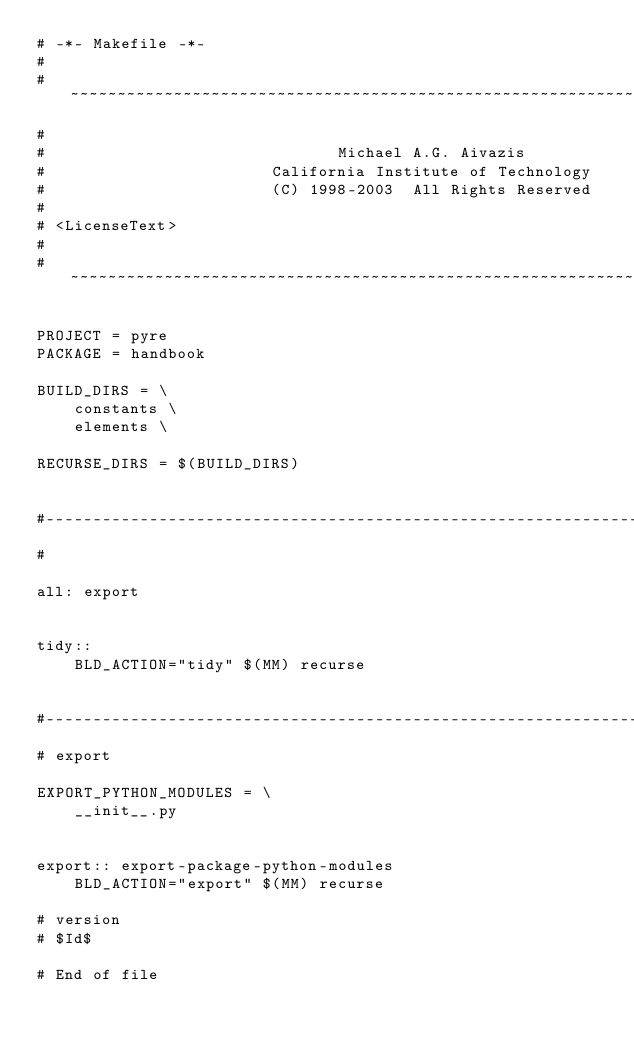Convert code to text. <code><loc_0><loc_0><loc_500><loc_500><_ObjectiveC_># -*- Makefile -*-
#
# ~~~~~~~~~~~~~~~~~~~~~~~~~~~~~~~~~~~~~~~~~~~~~~~~~~~~~~~~~~~~~~~~~~~~~~~~~
#
#                               Michael A.G. Aivazis
#                        California Institute of Technology
#                        (C) 1998-2003  All Rights Reserved
#
# <LicenseText>
#
# ~~~~~~~~~~~~~~~~~~~~~~~~~~~~~~~~~~~~~~~~~~~~~~~~~~~~~~~~~~~~~~~~~~~~~~~~~

PROJECT = pyre
PACKAGE = handbook

BUILD_DIRS = \
    constants \
    elements \

RECURSE_DIRS = $(BUILD_DIRS)


#--------------------------------------------------------------------------
#

all: export


tidy::
	BLD_ACTION="tidy" $(MM) recurse


#--------------------------------------------------------------------------
# export

EXPORT_PYTHON_MODULES = \
    __init__.py


export:: export-package-python-modules
	BLD_ACTION="export" $(MM) recurse

# version
# $Id$

# End of file
</code> 